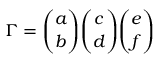<formula> <loc_0><loc_0><loc_500><loc_500>{ \Gamma } = { \binom { a } { b } } { \binom { c } { d } } { \binom { e } { f } }</formula> 